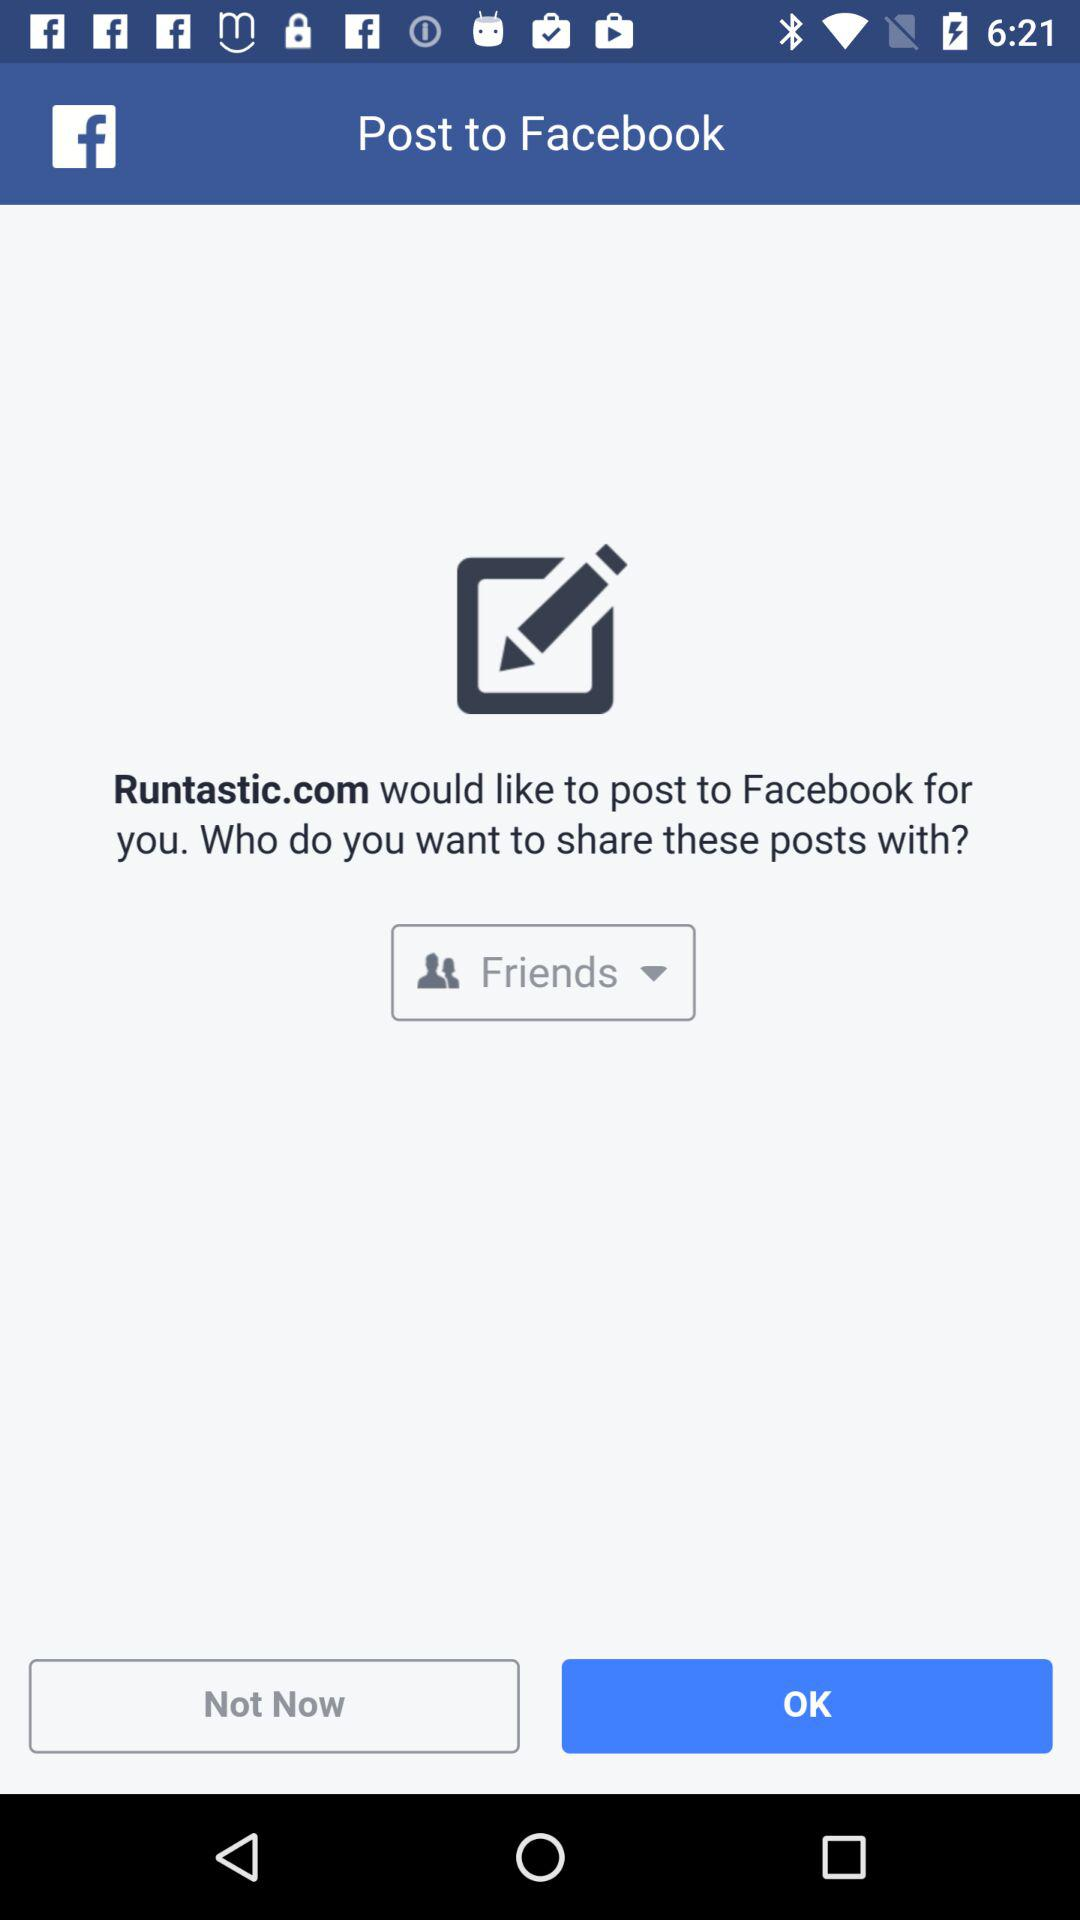Who would like to post to "FACEBOOK"? The application "Runtastic.com" would like to post to "FACEBOOK". 